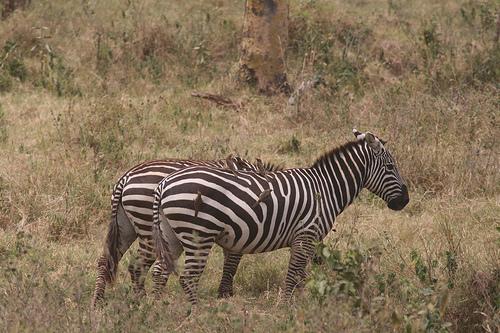Is the baby zebra a lot smaller than the mama zebra?
Quick response, please. No. Is this animal in your natural habitat?
Answer briefly. Yes. Are the zebra tails pointing in the same direction?
Give a very brief answer. Yes. Is one of the zebras looking at the camera?
Answer briefly. No. Which front foot does the rear zebra have forward?
Give a very brief answer. Right. Are their ears laying back?
Quick response, please. Yes. Does the giraffe in the foreground have any abnormalities in the striped pattern of his fur?
Answer briefly. No. Are the zebras running?
Concise answer only. No. What is the back zebra swishing?
Quick response, please. Tail. Are these animals close enough  that one might suspect oneself of blurred vision?
Write a very short answer. No. 